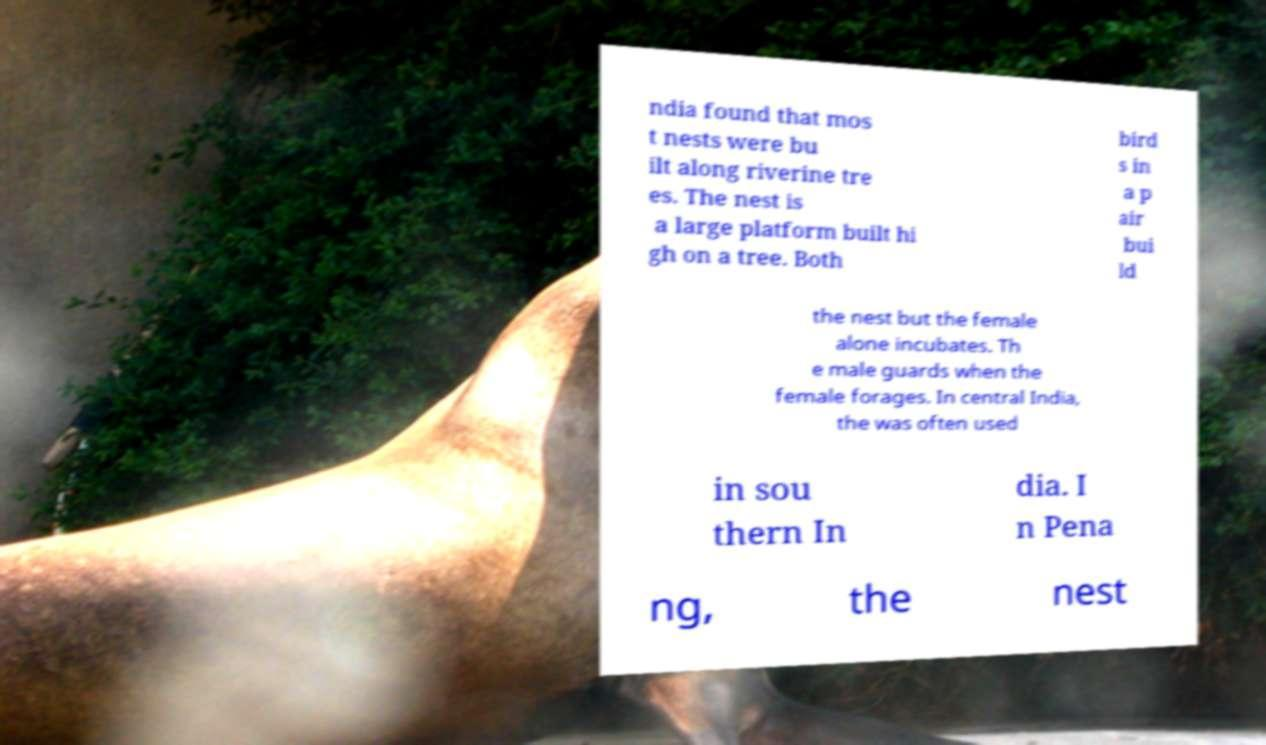I need the written content from this picture converted into text. Can you do that? ndia found that mos t nests were bu ilt along riverine tre es. The nest is a large platform built hi gh on a tree. Both bird s in a p air bui ld the nest but the female alone incubates. Th e male guards when the female forages. In central India, the was often used in sou thern In dia. I n Pena ng, the nest 